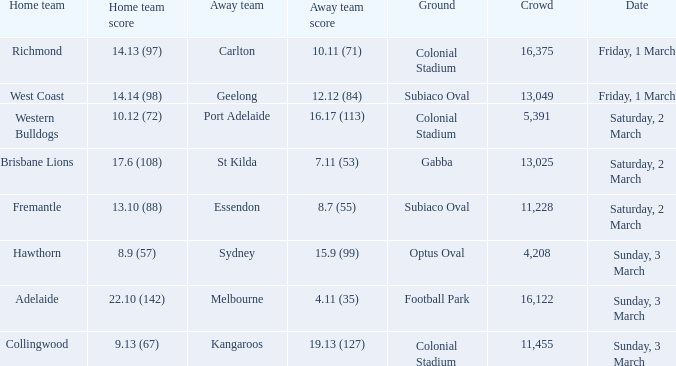When was the away team geelong? Friday, 1 March. 